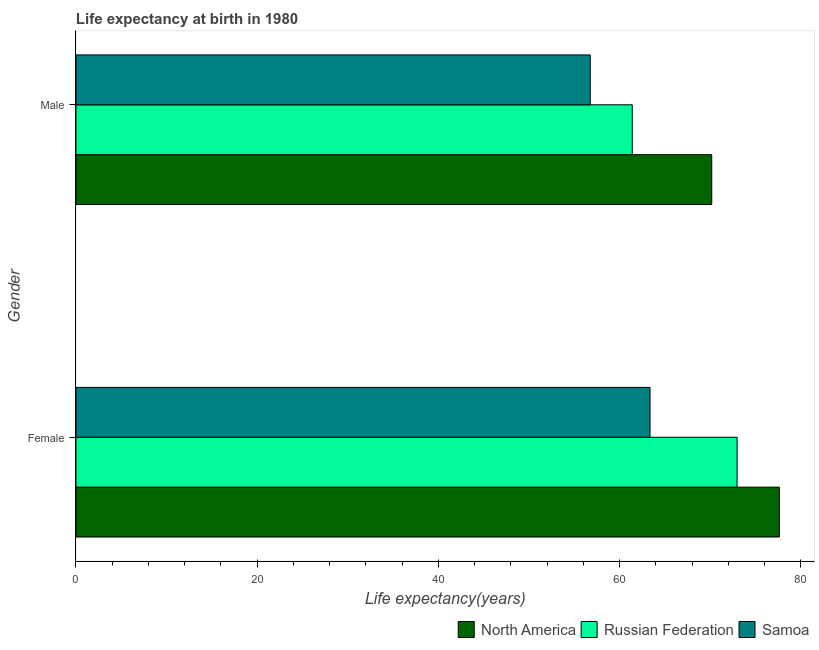How many different coloured bars are there?
Offer a terse response. 3. How many groups of bars are there?
Provide a succinct answer. 2. How many bars are there on the 2nd tick from the bottom?
Provide a short and direct response. 3. What is the label of the 2nd group of bars from the top?
Offer a terse response. Female. What is the life expectancy(female) in Samoa?
Your response must be concise. 63.35. Across all countries, what is the maximum life expectancy(male)?
Provide a short and direct response. 70.16. Across all countries, what is the minimum life expectancy(male)?
Provide a succinct answer. 56.75. In which country was the life expectancy(male) minimum?
Your response must be concise. Samoa. What is the total life expectancy(female) in the graph?
Give a very brief answer. 213.93. What is the difference between the life expectancy(female) in Samoa and that in Russian Federation?
Offer a terse response. -9.61. What is the difference between the life expectancy(male) in Samoa and the life expectancy(female) in Russian Federation?
Offer a terse response. -16.21. What is the average life expectancy(female) per country?
Make the answer very short. 71.31. What is the difference between the life expectancy(male) and life expectancy(female) in North America?
Your response must be concise. -7.46. In how many countries, is the life expectancy(male) greater than 8 years?
Provide a succinct answer. 3. What is the ratio of the life expectancy(male) in Russian Federation to that in Samoa?
Your response must be concise. 1.08. Is the life expectancy(female) in Samoa less than that in Russian Federation?
Keep it short and to the point. Yes. In how many countries, is the life expectancy(male) greater than the average life expectancy(male) taken over all countries?
Your answer should be compact. 1. What does the 1st bar from the top in Male represents?
Your answer should be very brief. Samoa. What does the 3rd bar from the bottom in Female represents?
Offer a terse response. Samoa. How many countries are there in the graph?
Your answer should be compact. 3. Does the graph contain grids?
Keep it short and to the point. No. How are the legend labels stacked?
Keep it short and to the point. Horizontal. What is the title of the graph?
Keep it short and to the point. Life expectancy at birth in 1980. Does "Japan" appear as one of the legend labels in the graph?
Keep it short and to the point. No. What is the label or title of the X-axis?
Provide a succinct answer. Life expectancy(years). What is the Life expectancy(years) of North America in Female?
Offer a very short reply. 77.62. What is the Life expectancy(years) of Russian Federation in Female?
Give a very brief answer. 72.96. What is the Life expectancy(years) of Samoa in Female?
Provide a short and direct response. 63.35. What is the Life expectancy(years) in North America in Male?
Your response must be concise. 70.16. What is the Life expectancy(years) in Russian Federation in Male?
Offer a very short reply. 61.39. What is the Life expectancy(years) of Samoa in Male?
Provide a short and direct response. 56.75. Across all Gender, what is the maximum Life expectancy(years) in North America?
Offer a very short reply. 77.62. Across all Gender, what is the maximum Life expectancy(years) in Russian Federation?
Provide a succinct answer. 72.96. Across all Gender, what is the maximum Life expectancy(years) of Samoa?
Your answer should be very brief. 63.35. Across all Gender, what is the minimum Life expectancy(years) in North America?
Offer a very short reply. 70.16. Across all Gender, what is the minimum Life expectancy(years) of Russian Federation?
Your response must be concise. 61.39. Across all Gender, what is the minimum Life expectancy(years) of Samoa?
Provide a short and direct response. 56.75. What is the total Life expectancy(years) in North America in the graph?
Give a very brief answer. 147.78. What is the total Life expectancy(years) in Russian Federation in the graph?
Make the answer very short. 134.35. What is the total Life expectancy(years) of Samoa in the graph?
Keep it short and to the point. 120.1. What is the difference between the Life expectancy(years) in North America in Female and that in Male?
Give a very brief answer. 7.46. What is the difference between the Life expectancy(years) of Russian Federation in Female and that in Male?
Your answer should be very brief. 11.57. What is the difference between the Life expectancy(years) in North America in Female and the Life expectancy(years) in Russian Federation in Male?
Your answer should be very brief. 16.23. What is the difference between the Life expectancy(years) in North America in Female and the Life expectancy(years) in Samoa in Male?
Offer a very short reply. 20.87. What is the difference between the Life expectancy(years) of Russian Federation in Female and the Life expectancy(years) of Samoa in Male?
Provide a succinct answer. 16.21. What is the average Life expectancy(years) of North America per Gender?
Offer a very short reply. 73.89. What is the average Life expectancy(years) of Russian Federation per Gender?
Offer a terse response. 67.17. What is the average Life expectancy(years) of Samoa per Gender?
Keep it short and to the point. 60.05. What is the difference between the Life expectancy(years) in North America and Life expectancy(years) in Russian Federation in Female?
Ensure brevity in your answer.  4.66. What is the difference between the Life expectancy(years) of North America and Life expectancy(years) of Samoa in Female?
Your answer should be compact. 14.27. What is the difference between the Life expectancy(years) in Russian Federation and Life expectancy(years) in Samoa in Female?
Your response must be concise. 9.61. What is the difference between the Life expectancy(years) of North America and Life expectancy(years) of Russian Federation in Male?
Your response must be concise. 8.77. What is the difference between the Life expectancy(years) in North America and Life expectancy(years) in Samoa in Male?
Give a very brief answer. 13.41. What is the difference between the Life expectancy(years) in Russian Federation and Life expectancy(years) in Samoa in Male?
Your response must be concise. 4.64. What is the ratio of the Life expectancy(years) of North America in Female to that in Male?
Ensure brevity in your answer.  1.11. What is the ratio of the Life expectancy(years) of Russian Federation in Female to that in Male?
Make the answer very short. 1.19. What is the ratio of the Life expectancy(years) of Samoa in Female to that in Male?
Ensure brevity in your answer.  1.12. What is the difference between the highest and the second highest Life expectancy(years) in North America?
Offer a very short reply. 7.46. What is the difference between the highest and the second highest Life expectancy(years) in Russian Federation?
Give a very brief answer. 11.57. What is the difference between the highest and the second highest Life expectancy(years) in Samoa?
Keep it short and to the point. 6.6. What is the difference between the highest and the lowest Life expectancy(years) in North America?
Keep it short and to the point. 7.46. What is the difference between the highest and the lowest Life expectancy(years) in Russian Federation?
Ensure brevity in your answer.  11.57. 